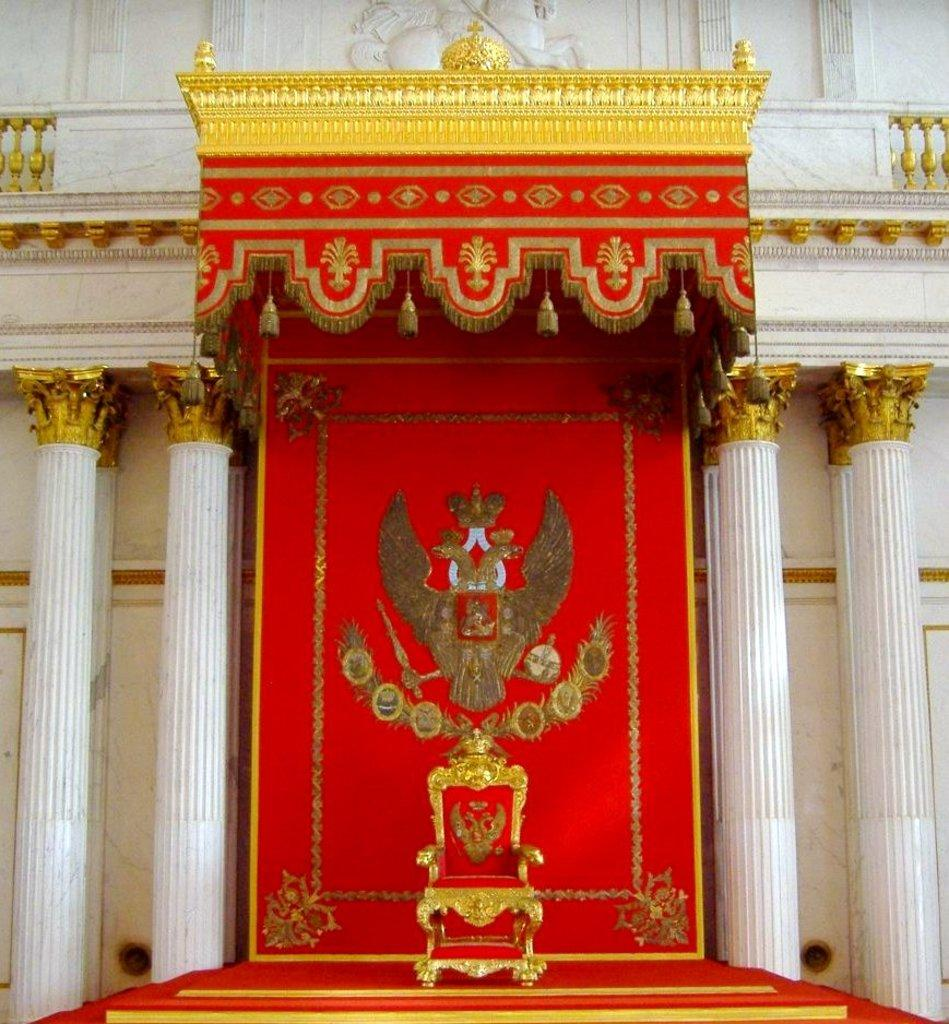What type of structure is depicted in the image? The image is of a building. Can you identify any specific features of the building? Yes, there are pillars and a sculpture at the top of the building on the wall. What is located in the foreground of the image? There is a staircase in the foreground of the image. Are there any objects or furniture inside the building? Yes, there is a chair in the image. Can you tell me how many jewels are on the donkey in the image? There is no donkey or jewels present in the image. What type of calculator is being used by the person in the image? There is no person or calculator present in the image. 